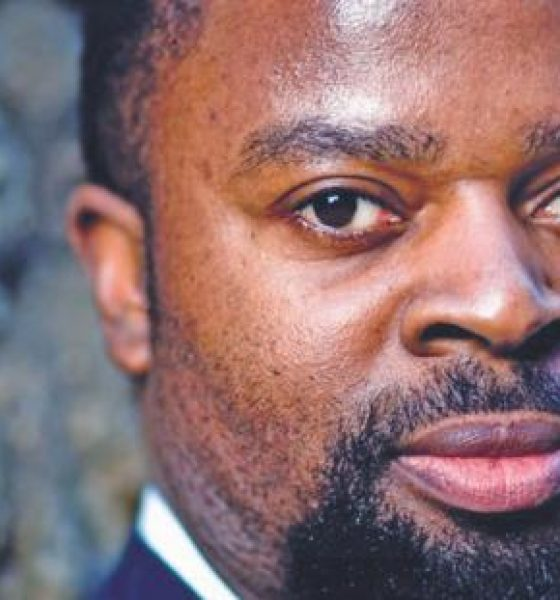Create a detailed backstory where this individual is an undercover agent. What mission are they currently on? This individual is an undercover agent working for an international intelligence agency. With a background as a top-tier lawyer, known for their sharp intellect and exceptional negotiation skills, they were recruited for their ability to blend seamlessly into high-stakes environments. The photograph captures them in their latest assignment: infiltrating a powerful global conglomerate suspected of illegal arms trade. They've spent months building their cover as a corporate consultant, gathering critical data and waiting for the perfect moment to dismantle the organization's operations from within. Their serious expression reflects the weight of their mission and the constant danger they face. 